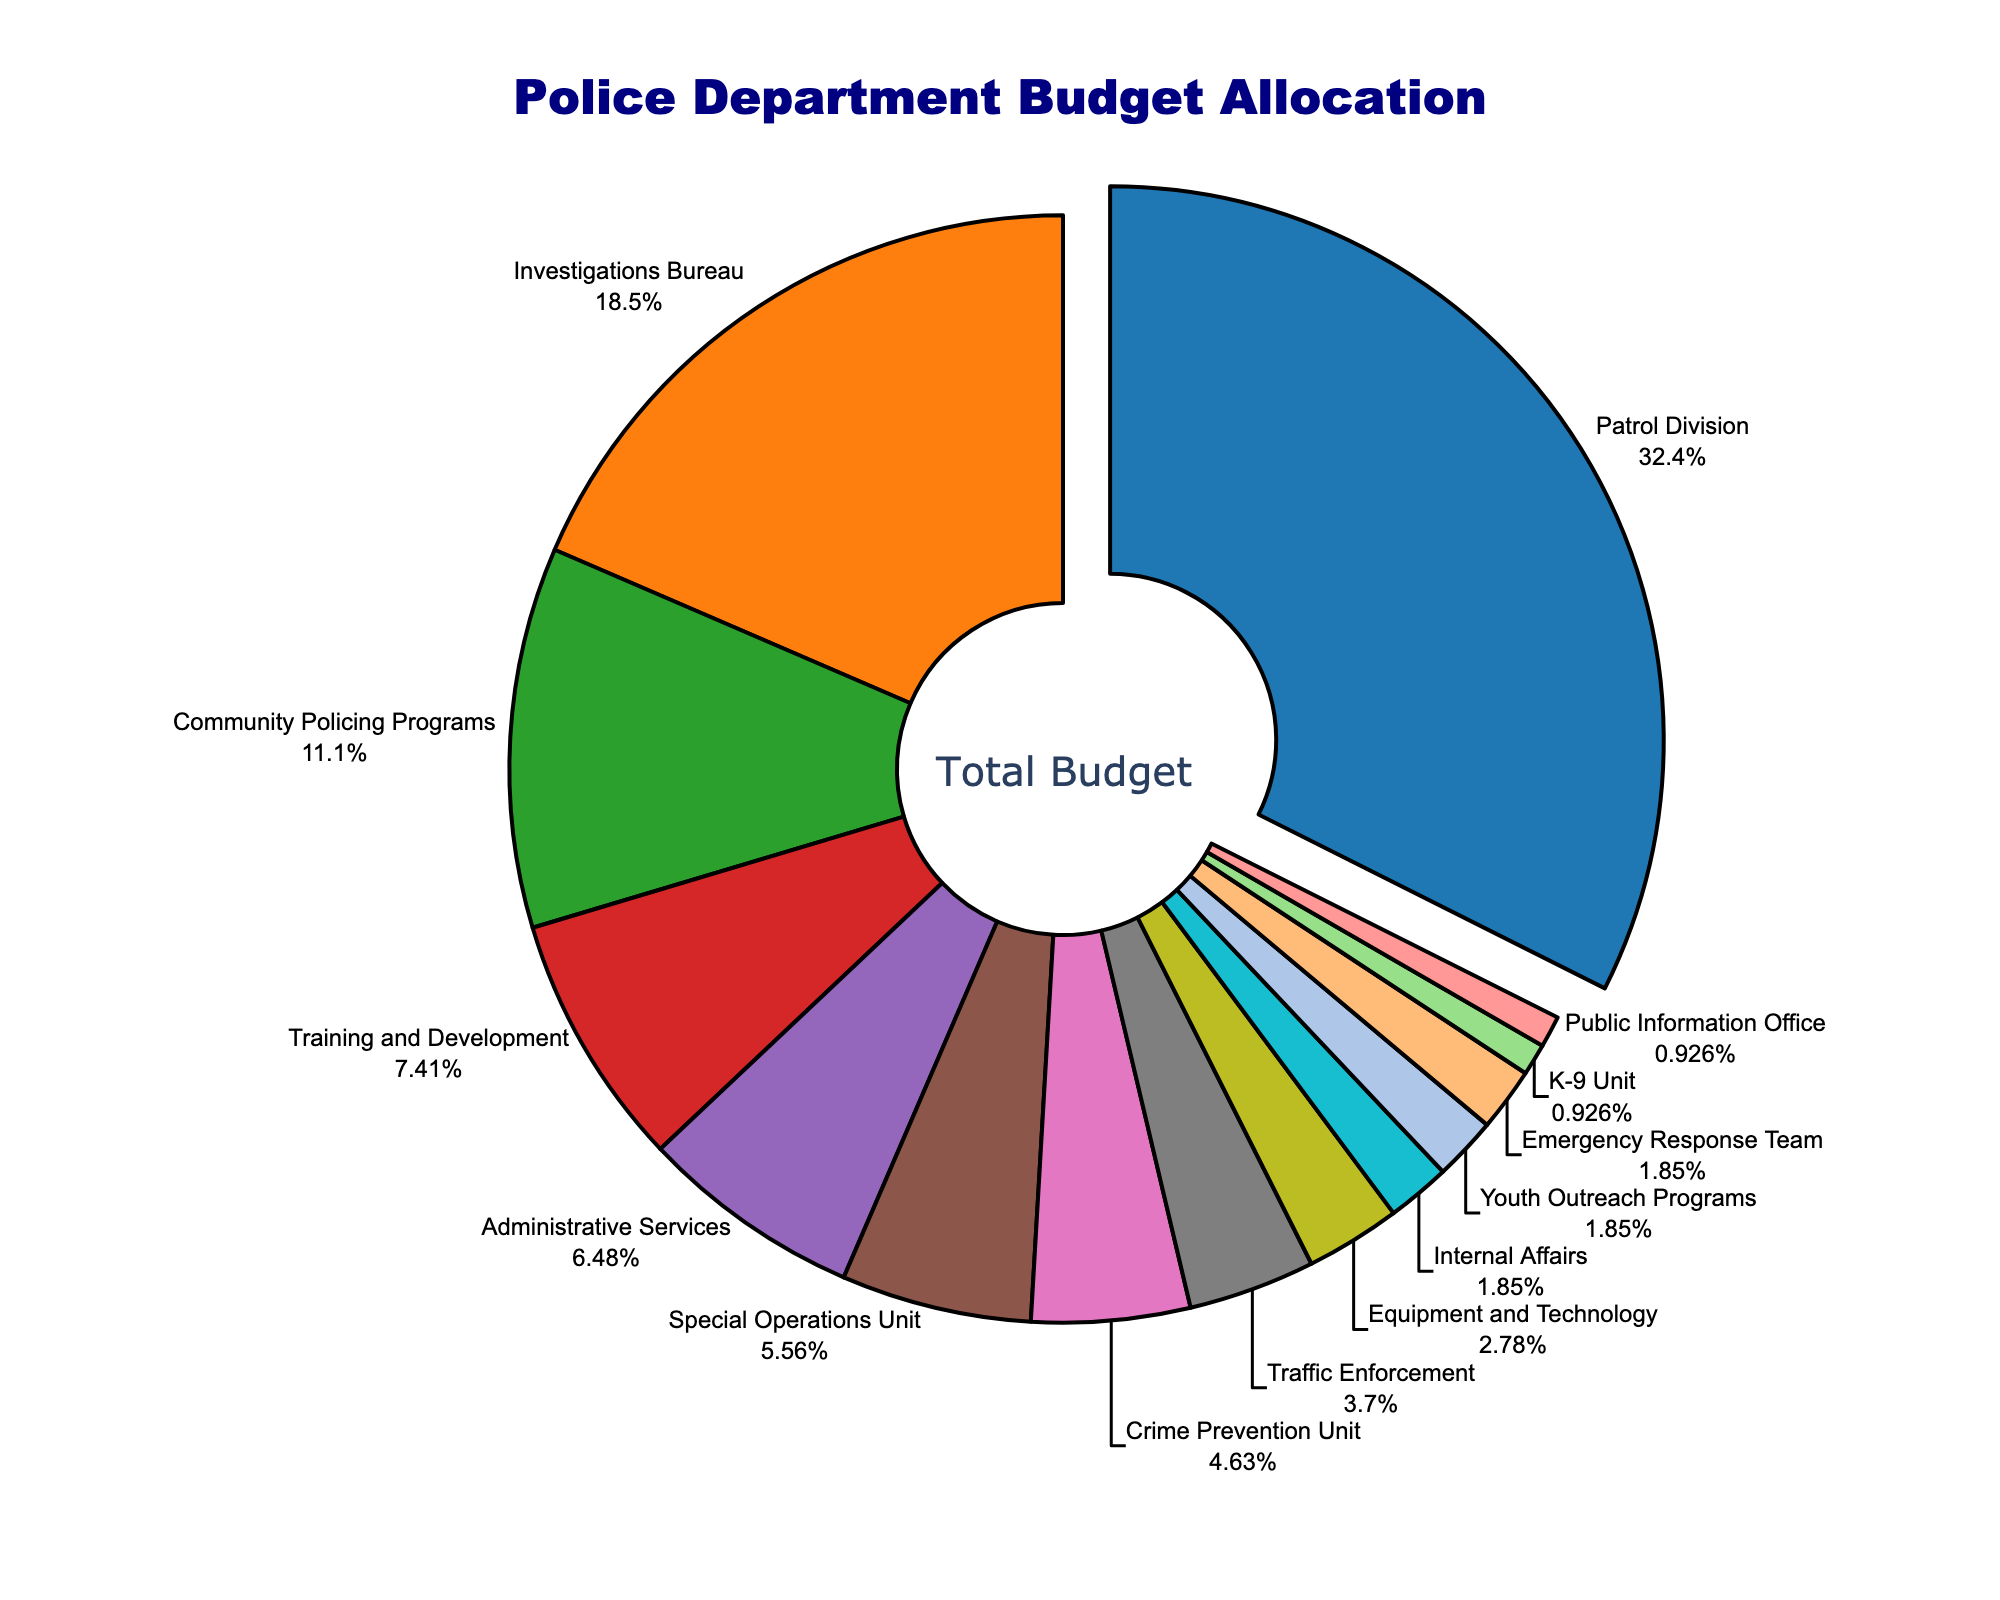What is the category with the highest budget allocation? The Patrol Division has the largest slice pulled out, indicating it is the category with the highest budget allocation. The text shows 35%.
Answer: Patrol Division What is the total percentage allocated to Community Policing Programs and Training and Development combined? Add the percentages allocated to Community Policing Programs (12%) and Training and Development (8%): 12% + 8% = 20%.
Answer: 20% Which category receives a smaller budget: Traffic Enforcement or Equipment and Technology? Traffic Enforcement has a percentage of 4%, while Equipment and Technology has 3%. Since 3% is less than 4%, Equipment and Technology receives a smaller budget.
Answer: Equipment and Technology If the budget of the Patrol Division is zeroed out and its percentage is redistributed evenly among the remaining categories, what percentage will each remaining category receive? Total remaining categories have a combined percentage of 65% (100% - 35% for Patrol Division). Redistributing this 35% evenly among 13 remaining categories gives an additional percentage of 35/13 ≈ 2.69% for each. Add 2.69% to each original percentage.
Answer: Varies (Example: Investigations Bureau would receive 20% + 2.69% ≈ 22.69%) What category has the lowest budget allocation, and what is its percentage? The K-9 Unit and Public Information Office both share the smallest slices with 1% each as per the pie chart and text.
Answer: K-9 Unit and Public Information Office How much higher is the percentage allocation of the Investigations Bureau compared to the Special Operations Unit? Subtract the percentage of the Special Operations Unit (6%) from that of the Investigations Bureau (20%): 20% - 6% = 14%.
Answer: 14% What is the combined allocation for Emergency Response Team and Youth Outreach Programs? Add their percentages: Emergency Response Team (2%) + Youth Outreach Programs (2%): 2% + 2% = 4%.
Answer: 4% Which categories have budget allocations less than or equal to 2%? Categories with percentages 2% or below are: Internal Affairs (2%), Youth Outreach Programs (2%), Emergency Response Team (2%), K-9 Unit (1%), and Public Information Office (1%).
Answer: Internal Affairs, Youth Outreach Programs, Emergency Response Team, K-9 Unit, Public Information Office Compare the budget allocations between Community Policing Programs and Administrative Services. Community Policing Programs has 12%, whereas Administrative Services has 7%. Since 12% is greater than 7%, Community Policing Programs has a higher budget allocation.
Answer: Community Policing Programs What percentage of the budget is allocated to the Special Operations Unit, Crime Prevention Unit, and Training and Development combined? Add the percentages of the Special Operations Unit (6%), Crime Prevention Unit (5%), and Training and Development (8%): 6% + 5% + 8% = 19%.
Answer: 19% 